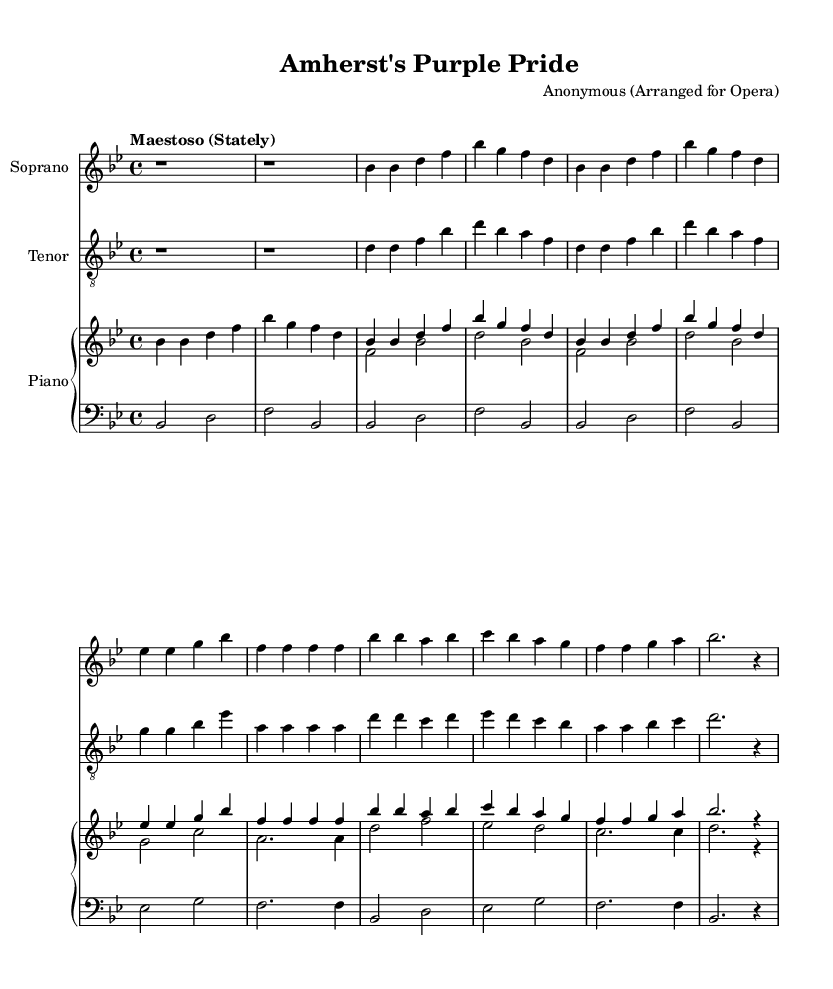What is the key signature of this music? The key signature is identified at the beginning of the staff; it has two flats, indicating the key of B flat major.
Answer: B flat major What is the time signature of this piece? The time signature is found right after the key signature and indicates how many beats are in each measure; here it is 4 over 4.
Answer: 4/4 What tempo marking is indicated for this piece? The tempo marking appears at the beginning of the score, stating "Maestoso," which means stately or majestic.
Answer: Maestoso How many measures are in the soprano voice section? By counting the segments divided by the vertical lines, there are eight measures in the soprano voice.
Answer: Eight What is the primary theme of the lyrics? The lyrics express loyalty and pride, celebrating the Amherst College community and values.
Answer: Loyalty and pride What is the name of this opera? The title is found in the header section above the music and states "Amherst's Purple Pride."
Answer: Amherst's Purple Pride What is the vocal range for the tenor voice? The tenor part indicates its vocal range above the staff; the tenor is written in "treble_8" which suggests a higher pitch range typically suited for tenors.
Answer: Treble 8 